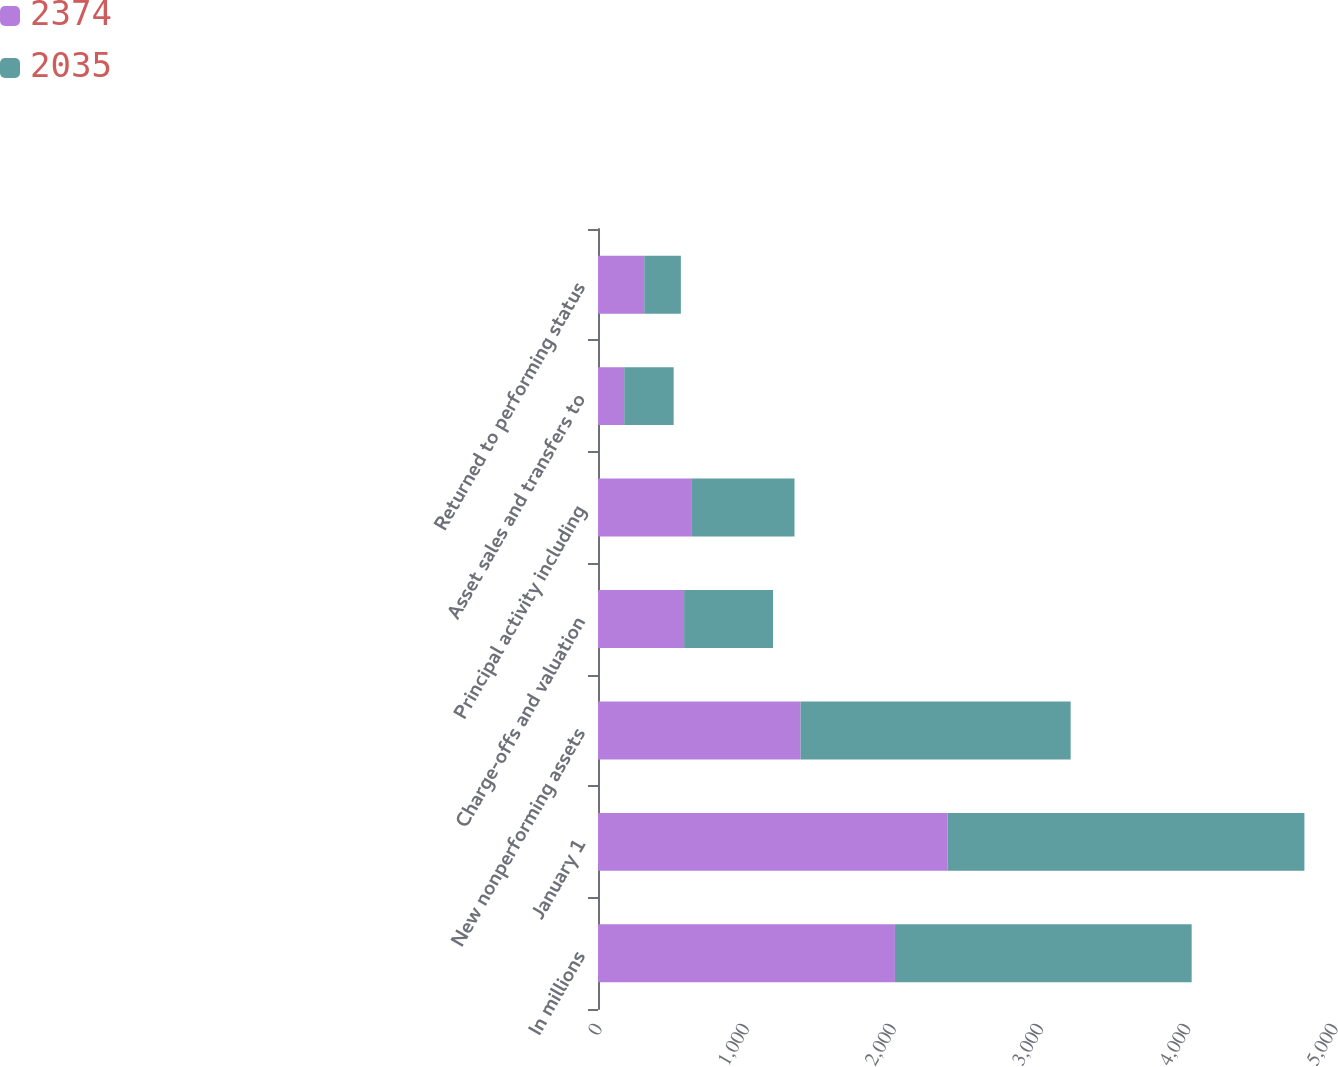Convert chart to OTSL. <chart><loc_0><loc_0><loc_500><loc_500><stacked_bar_chart><ecel><fcel>In millions<fcel>January 1<fcel>New nonperforming assets<fcel>Charge-offs and valuation<fcel>Principal activity including<fcel>Asset sales and transfers to<fcel>Returned to performing status<nl><fcel>2374<fcel>2017<fcel>2374<fcel>1376<fcel>585<fcel>638<fcel>178<fcel>314<nl><fcel>2035<fcel>2016<fcel>2425<fcel>1835<fcel>604<fcel>697<fcel>336<fcel>249<nl></chart> 